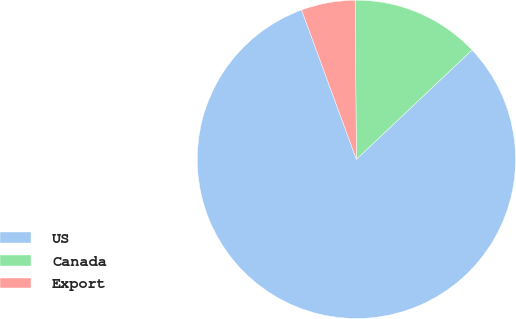Convert chart. <chart><loc_0><loc_0><loc_500><loc_500><pie_chart><fcel>US<fcel>Canada<fcel>Export<nl><fcel>81.46%<fcel>13.07%<fcel>5.47%<nl></chart> 